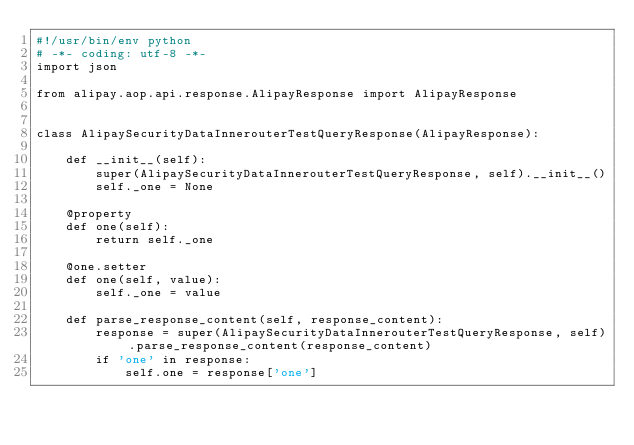<code> <loc_0><loc_0><loc_500><loc_500><_Python_>#!/usr/bin/env python
# -*- coding: utf-8 -*-
import json

from alipay.aop.api.response.AlipayResponse import AlipayResponse


class AlipaySecurityDataInnerouterTestQueryResponse(AlipayResponse):

    def __init__(self):
        super(AlipaySecurityDataInnerouterTestQueryResponse, self).__init__()
        self._one = None

    @property
    def one(self):
        return self._one

    @one.setter
    def one(self, value):
        self._one = value

    def parse_response_content(self, response_content):
        response = super(AlipaySecurityDataInnerouterTestQueryResponse, self).parse_response_content(response_content)
        if 'one' in response:
            self.one = response['one']
</code> 